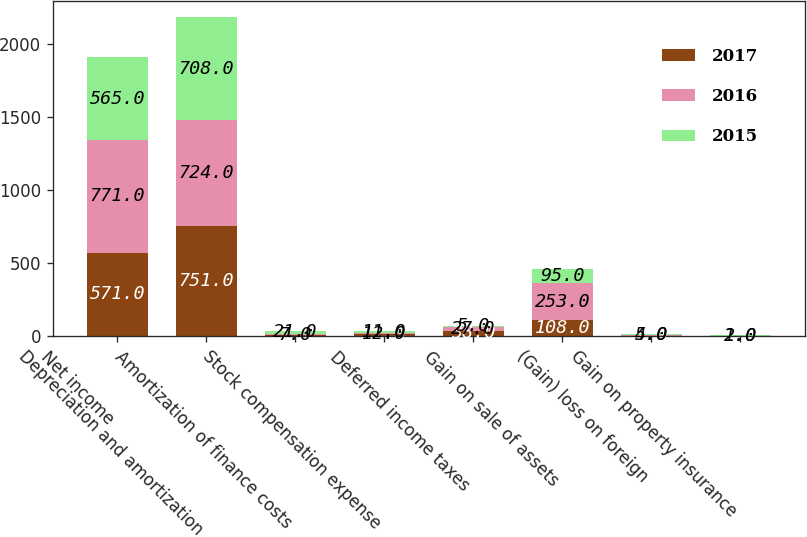<chart> <loc_0><loc_0><loc_500><loc_500><stacked_bar_chart><ecel><fcel>Net income<fcel>Depreciation and amortization<fcel>Amortization of finance costs<fcel>Stock compensation expense<fcel>Deferred income taxes<fcel>Gain on sale of assets<fcel>(Gain) loss on foreign<fcel>Gain on property insurance<nl><fcel>2017<fcel>571<fcel>751<fcel>7<fcel>11<fcel>38<fcel>108<fcel>2<fcel>1<nl><fcel>2016<fcel>771<fcel>724<fcel>7<fcel>12<fcel>27<fcel>253<fcel>4<fcel>1<nl><fcel>2015<fcel>565<fcel>708<fcel>21<fcel>11<fcel>5<fcel>95<fcel>5<fcel>2<nl></chart> 